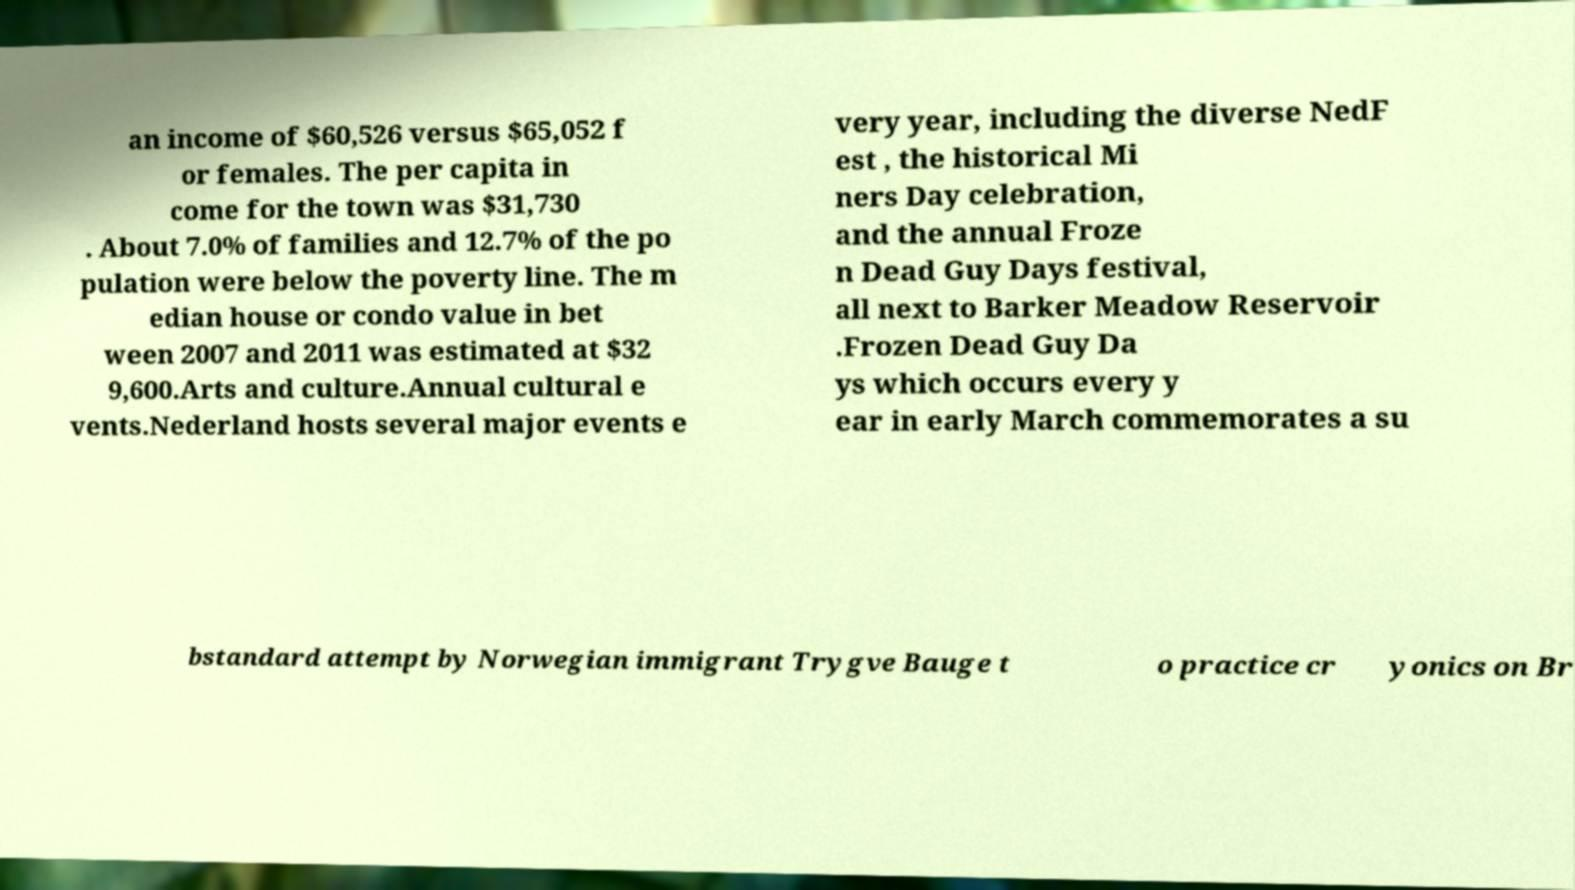There's text embedded in this image that I need extracted. Can you transcribe it verbatim? an income of $60,526 versus $65,052 f or females. The per capita in come for the town was $31,730 . About 7.0% of families and 12.7% of the po pulation were below the poverty line. The m edian house or condo value in bet ween 2007 and 2011 was estimated at $32 9,600.Arts and culture.Annual cultural e vents.Nederland hosts several major events e very year, including the diverse NedF est , the historical Mi ners Day celebration, and the annual Froze n Dead Guy Days festival, all next to Barker Meadow Reservoir .Frozen Dead Guy Da ys which occurs every y ear in early March commemorates a su bstandard attempt by Norwegian immigrant Trygve Bauge t o practice cr yonics on Br 